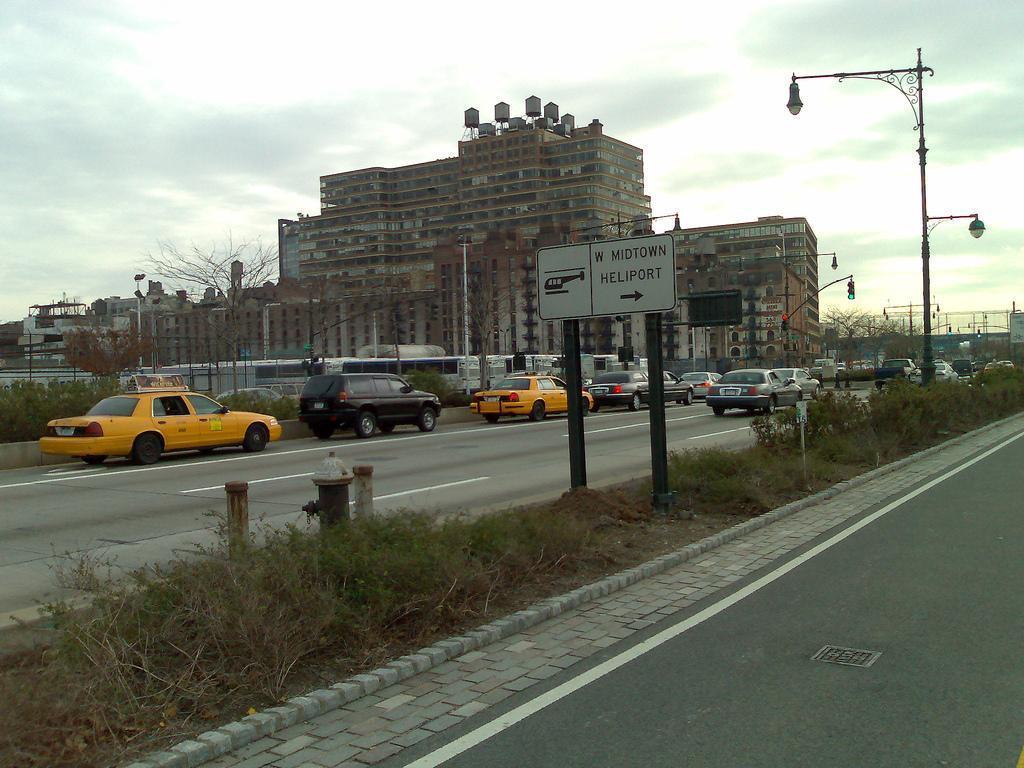How many yellow taxis are in the picture?
Give a very brief answer. 2. How many cars are there with yellow color?
Give a very brief answer. 2. How many yellow car in the road?
Give a very brief answer. 2. 